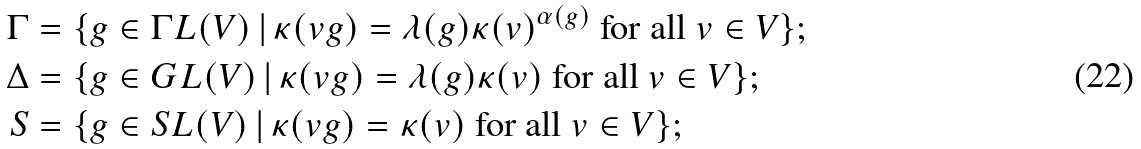<formula> <loc_0><loc_0><loc_500><loc_500>\Gamma & = \{ g \in \Gamma L ( V ) \, | \, \kappa ( v g ) = \lambda ( g ) \kappa ( v ) ^ { \alpha ( g ) } \text { for all } v \in V \} ; \\ \Delta & = \{ g \in G L ( V ) \, | \, \kappa ( v g ) = \lambda ( g ) \kappa ( v ) \text { for all } v \in V \} ; \\ S & = \{ g \in S L ( V ) \, | \, \kappa ( v g ) = \kappa ( v ) \text { for all } v \in V \} ;</formula> 